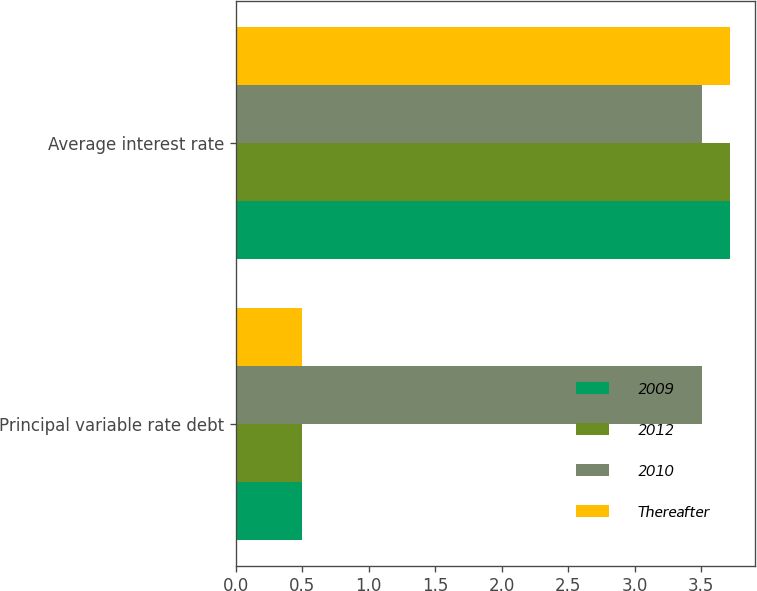<chart> <loc_0><loc_0><loc_500><loc_500><stacked_bar_chart><ecel><fcel>Principal variable rate debt<fcel>Average interest rate<nl><fcel>2009<fcel>0.5<fcel>3.72<nl><fcel>2012<fcel>0.5<fcel>3.72<nl><fcel>2010<fcel>3.51<fcel>3.51<nl><fcel>Thereafter<fcel>0.5<fcel>3.72<nl></chart> 